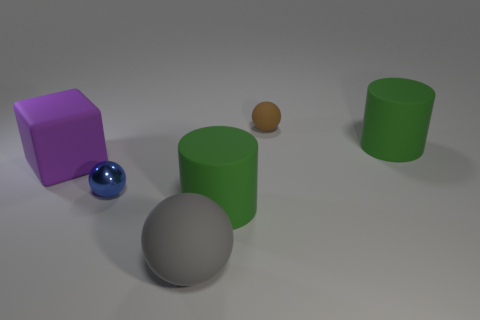Subtract all yellow cylinders. Subtract all blue cubes. How many cylinders are left? 2 Add 4 blue spheres. How many objects exist? 10 Subtract all cubes. How many objects are left? 5 Add 4 large purple cubes. How many large purple cubes are left? 5 Add 2 big cylinders. How many big cylinders exist? 4 Subtract 0 purple balls. How many objects are left? 6 Subtract all tiny blue objects. Subtract all big rubber blocks. How many objects are left? 4 